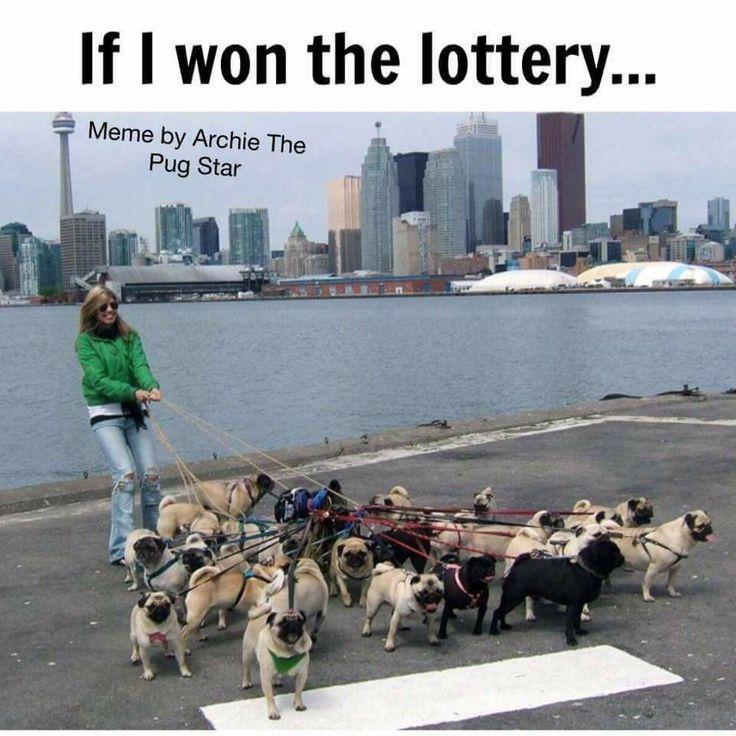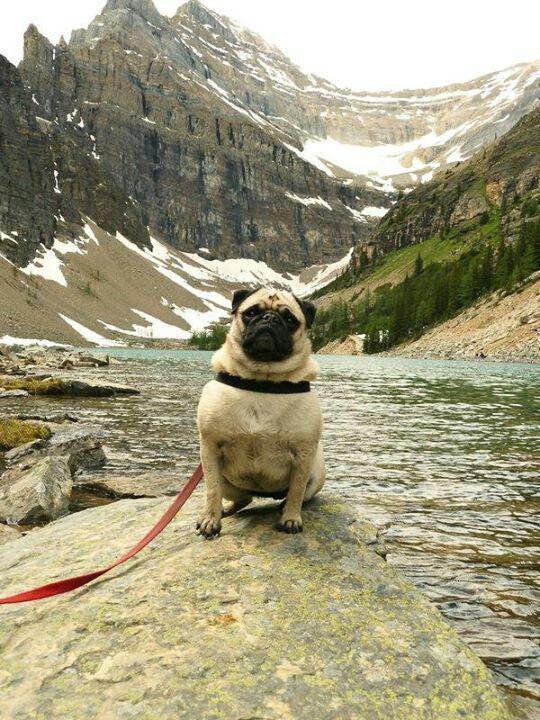The first image is the image on the left, the second image is the image on the right. For the images shown, is this caption "One image contains fewer than 3 pugs, and all pugs are on a leash." true? Answer yes or no. Yes. 